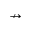Convert formula to latex. <formula><loc_0><loc_0><loc_500><loc_500>\nrightarrow</formula> 